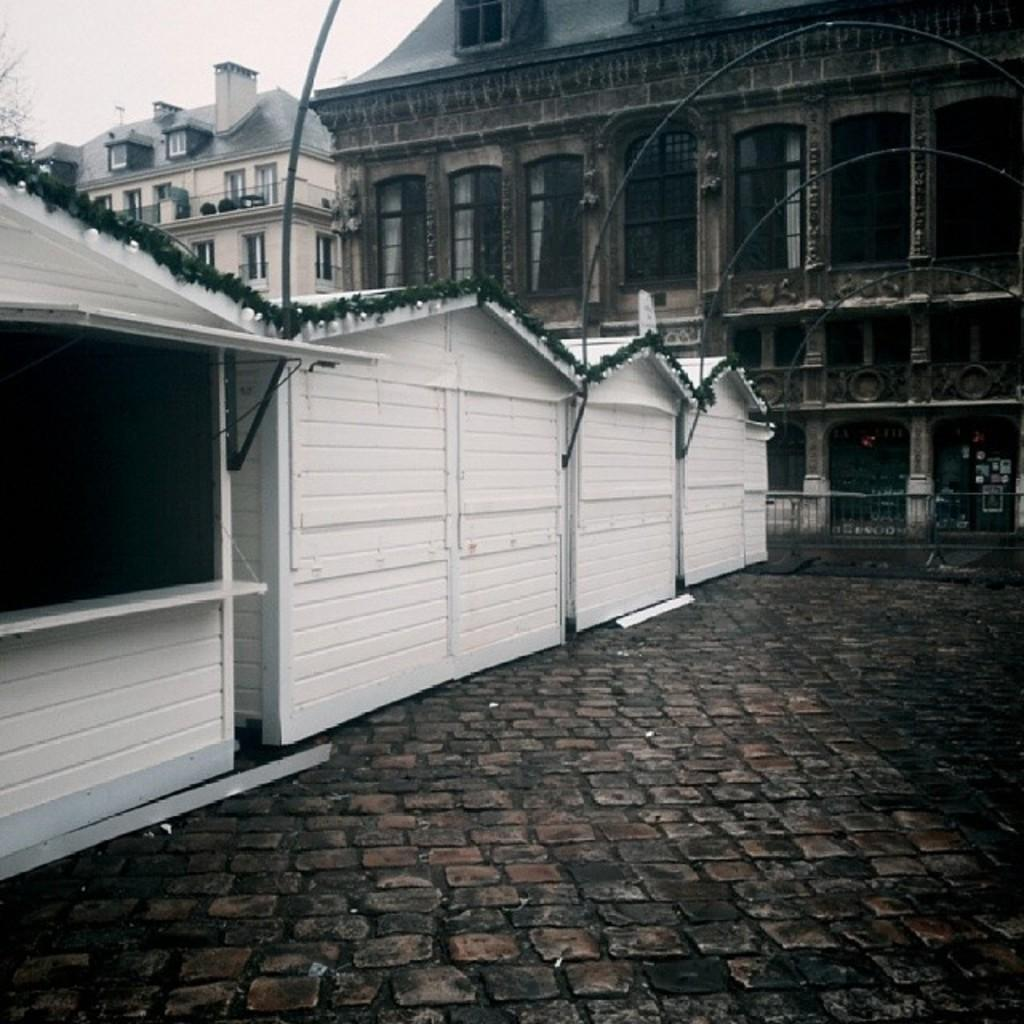What structures are located in the middle of the image? There are sheds in the middle of the image. What can be seen behind the sheds? There are buildings and trees behind the sheds. What is visible at the top of the image? The sky is visible at the top of the image. Can you tell me how many porters are carrying trays in the image? There are no porters or trays present in the image. What is the head of the person in the image doing? There is no person in the image, so it is not possible to describe the actions of their head. 